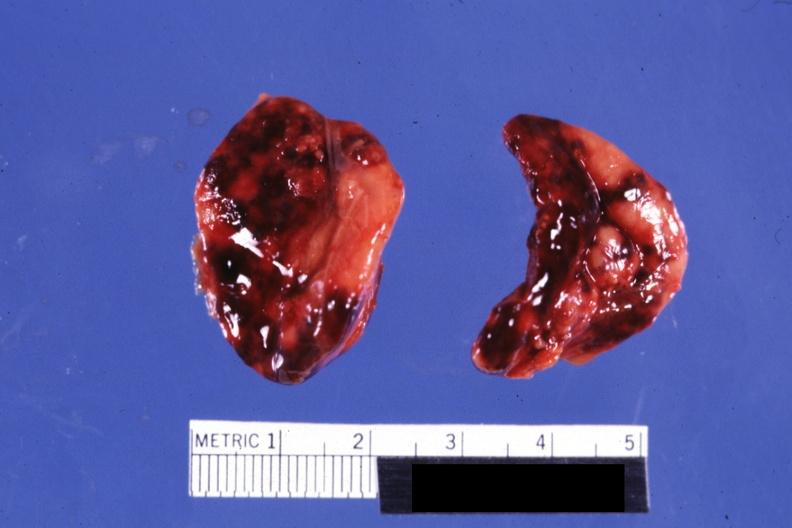what do focal hemorrhages looks like placental abruption?
Answer the question using a single word or phrase. Not know history 